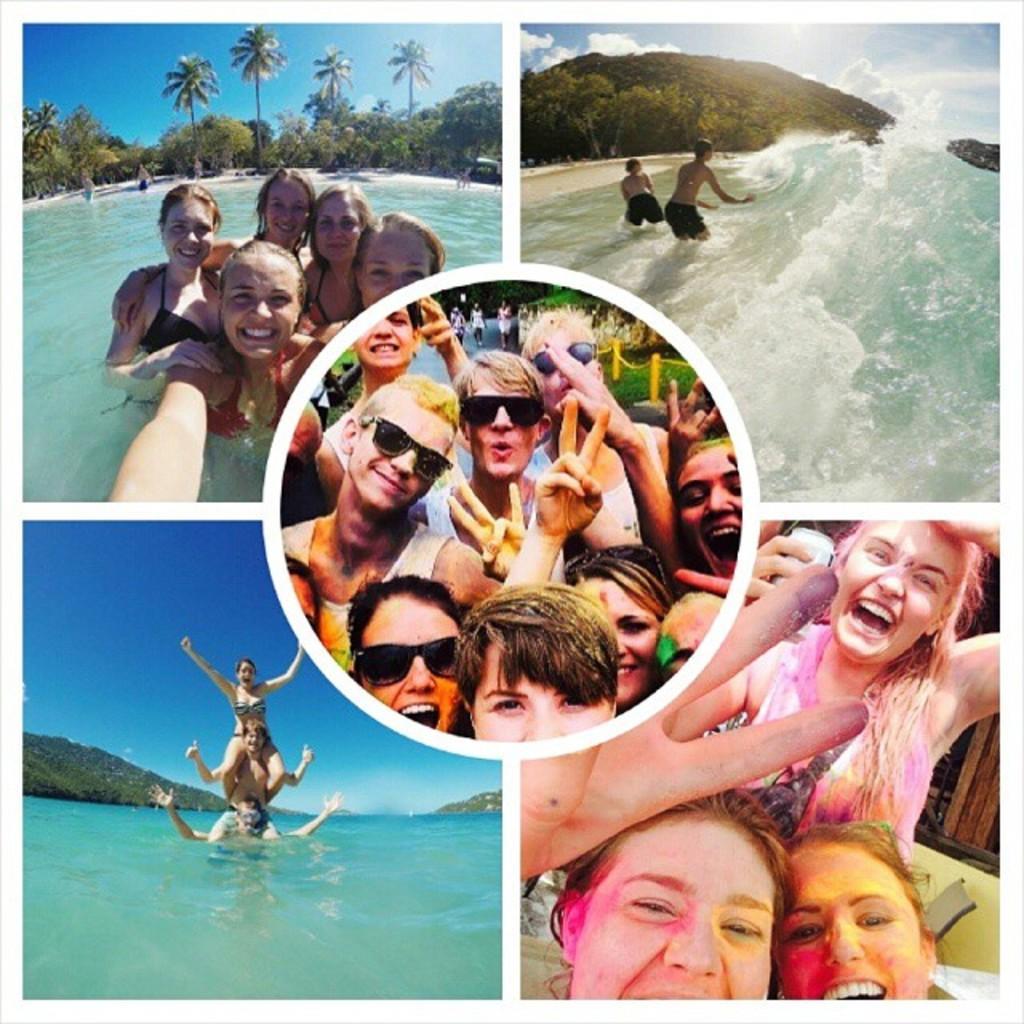In one or two sentences, can you explain what this image depicts? There is a college image of five different pictures. In two pictures, we can see only persons and remaining three pictures we can see persons in the water. 